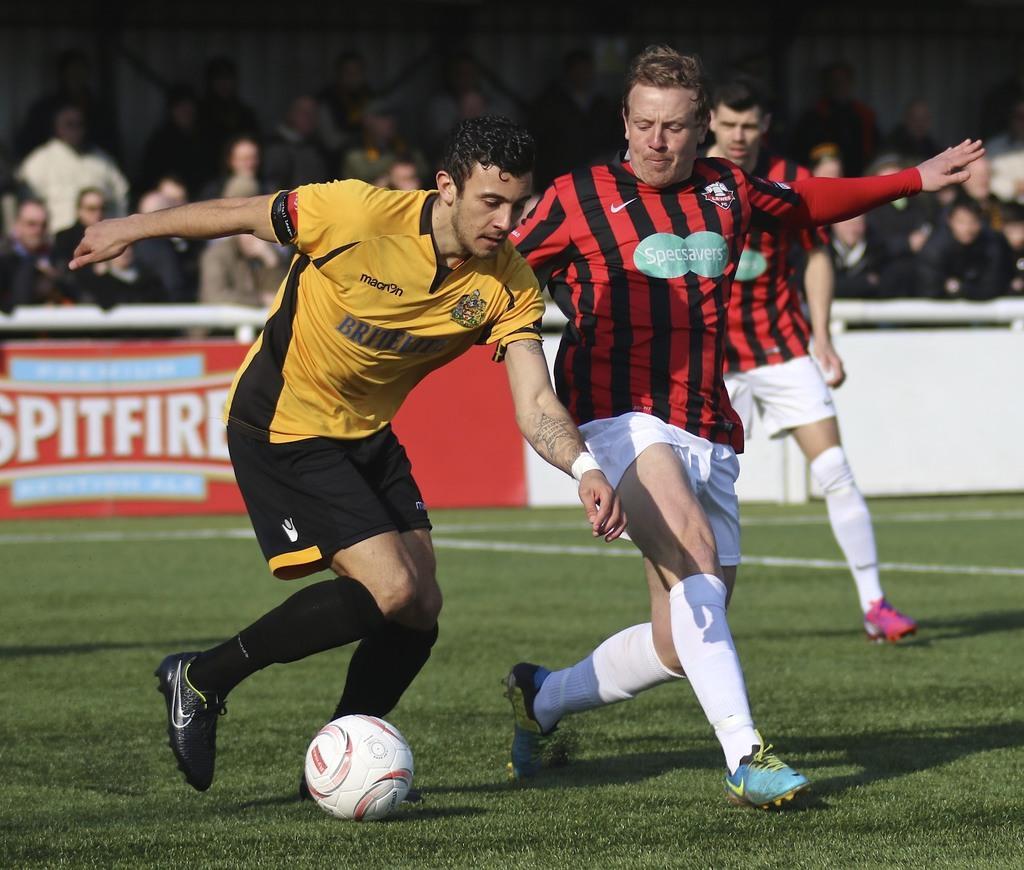Can you describe this image briefly? As we can see in the image there is grass, white color wall, banner and group of people. 